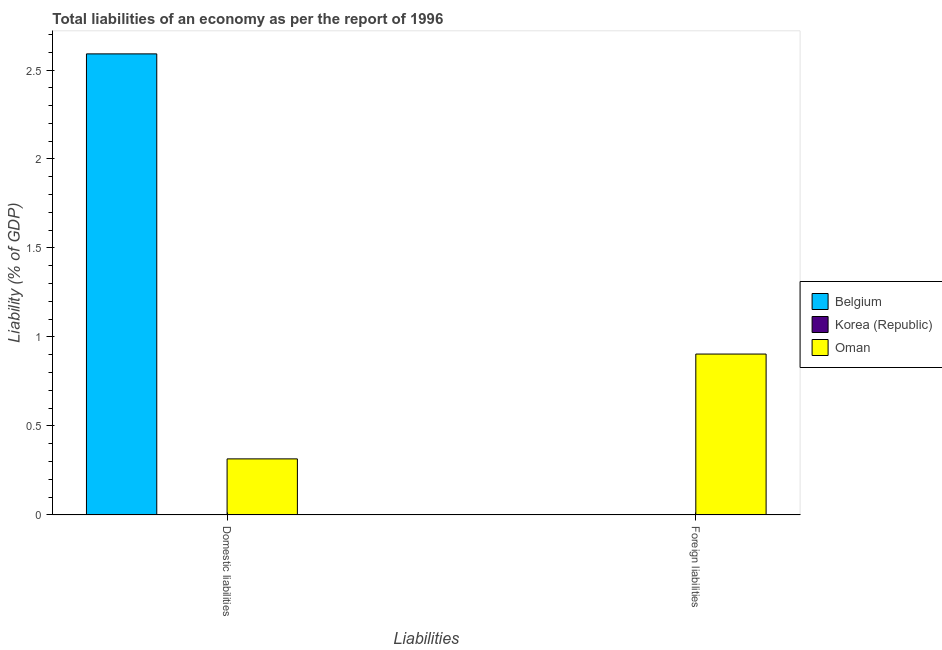How many different coloured bars are there?
Offer a terse response. 2. Are the number of bars per tick equal to the number of legend labels?
Give a very brief answer. No. Are the number of bars on each tick of the X-axis equal?
Make the answer very short. No. How many bars are there on the 2nd tick from the left?
Give a very brief answer. 1. How many bars are there on the 1st tick from the right?
Give a very brief answer. 1. What is the label of the 1st group of bars from the left?
Your response must be concise. Domestic liabilities. What is the incurrence of foreign liabilities in Korea (Republic)?
Keep it short and to the point. 0. Across all countries, what is the maximum incurrence of foreign liabilities?
Provide a succinct answer. 0.9. Across all countries, what is the minimum incurrence of foreign liabilities?
Your response must be concise. 0. In which country was the incurrence of foreign liabilities maximum?
Make the answer very short. Oman. What is the total incurrence of domestic liabilities in the graph?
Your answer should be very brief. 2.91. What is the difference between the incurrence of domestic liabilities in Belgium and that in Oman?
Keep it short and to the point. 2.28. What is the average incurrence of domestic liabilities per country?
Keep it short and to the point. 0.97. What is the difference between the incurrence of domestic liabilities and incurrence of foreign liabilities in Oman?
Your answer should be very brief. -0.59. In how many countries, is the incurrence of foreign liabilities greater than 2 %?
Provide a succinct answer. 0. Is the incurrence of domestic liabilities in Oman less than that in Belgium?
Provide a short and direct response. Yes. In how many countries, is the incurrence of foreign liabilities greater than the average incurrence of foreign liabilities taken over all countries?
Give a very brief answer. 1. How many bars are there?
Ensure brevity in your answer.  3. Are all the bars in the graph horizontal?
Ensure brevity in your answer.  No. What is the difference between two consecutive major ticks on the Y-axis?
Offer a very short reply. 0.5. Are the values on the major ticks of Y-axis written in scientific E-notation?
Make the answer very short. No. Does the graph contain any zero values?
Ensure brevity in your answer.  Yes. How are the legend labels stacked?
Provide a short and direct response. Vertical. What is the title of the graph?
Your answer should be compact. Total liabilities of an economy as per the report of 1996. What is the label or title of the X-axis?
Give a very brief answer. Liabilities. What is the label or title of the Y-axis?
Provide a succinct answer. Liability (% of GDP). What is the Liability (% of GDP) of Belgium in Domestic liabilities?
Give a very brief answer. 2.59. What is the Liability (% of GDP) of Korea (Republic) in Domestic liabilities?
Keep it short and to the point. 0. What is the Liability (% of GDP) in Oman in Domestic liabilities?
Provide a short and direct response. 0.31. What is the Liability (% of GDP) in Korea (Republic) in Foreign liabilities?
Provide a short and direct response. 0. What is the Liability (% of GDP) in Oman in Foreign liabilities?
Keep it short and to the point. 0.9. Across all Liabilities, what is the maximum Liability (% of GDP) of Belgium?
Provide a succinct answer. 2.59. Across all Liabilities, what is the maximum Liability (% of GDP) of Oman?
Offer a very short reply. 0.9. Across all Liabilities, what is the minimum Liability (% of GDP) of Oman?
Ensure brevity in your answer.  0.31. What is the total Liability (% of GDP) of Belgium in the graph?
Provide a short and direct response. 2.59. What is the total Liability (% of GDP) of Korea (Republic) in the graph?
Offer a terse response. 0. What is the total Liability (% of GDP) of Oman in the graph?
Give a very brief answer. 1.22. What is the difference between the Liability (% of GDP) of Oman in Domestic liabilities and that in Foreign liabilities?
Keep it short and to the point. -0.59. What is the difference between the Liability (% of GDP) in Belgium in Domestic liabilities and the Liability (% of GDP) in Oman in Foreign liabilities?
Give a very brief answer. 1.69. What is the average Liability (% of GDP) of Belgium per Liabilities?
Offer a terse response. 1.3. What is the average Liability (% of GDP) in Korea (Republic) per Liabilities?
Your answer should be compact. 0. What is the average Liability (% of GDP) in Oman per Liabilities?
Your answer should be compact. 0.61. What is the difference between the Liability (% of GDP) of Belgium and Liability (% of GDP) of Oman in Domestic liabilities?
Your answer should be compact. 2.28. What is the ratio of the Liability (% of GDP) in Oman in Domestic liabilities to that in Foreign liabilities?
Offer a very short reply. 0.35. What is the difference between the highest and the second highest Liability (% of GDP) in Oman?
Provide a succinct answer. 0.59. What is the difference between the highest and the lowest Liability (% of GDP) in Belgium?
Make the answer very short. 2.59. What is the difference between the highest and the lowest Liability (% of GDP) in Oman?
Make the answer very short. 0.59. 